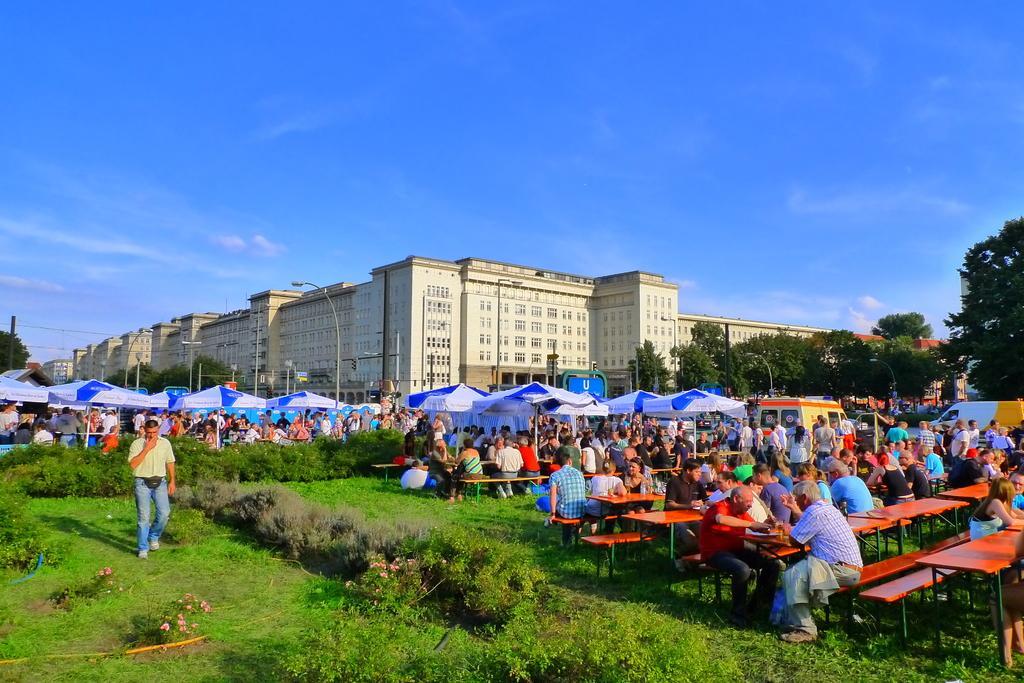Could you give a brief overview of what you see in this image? In this picture we can see grass and plants at the bottom, there are some people standing and some people are sitting on benches in the middle, we can also see a vehicle and umbrellas in the middle, in the background there are buildings, trees and poles, we can see the sky at the top of the picture. 